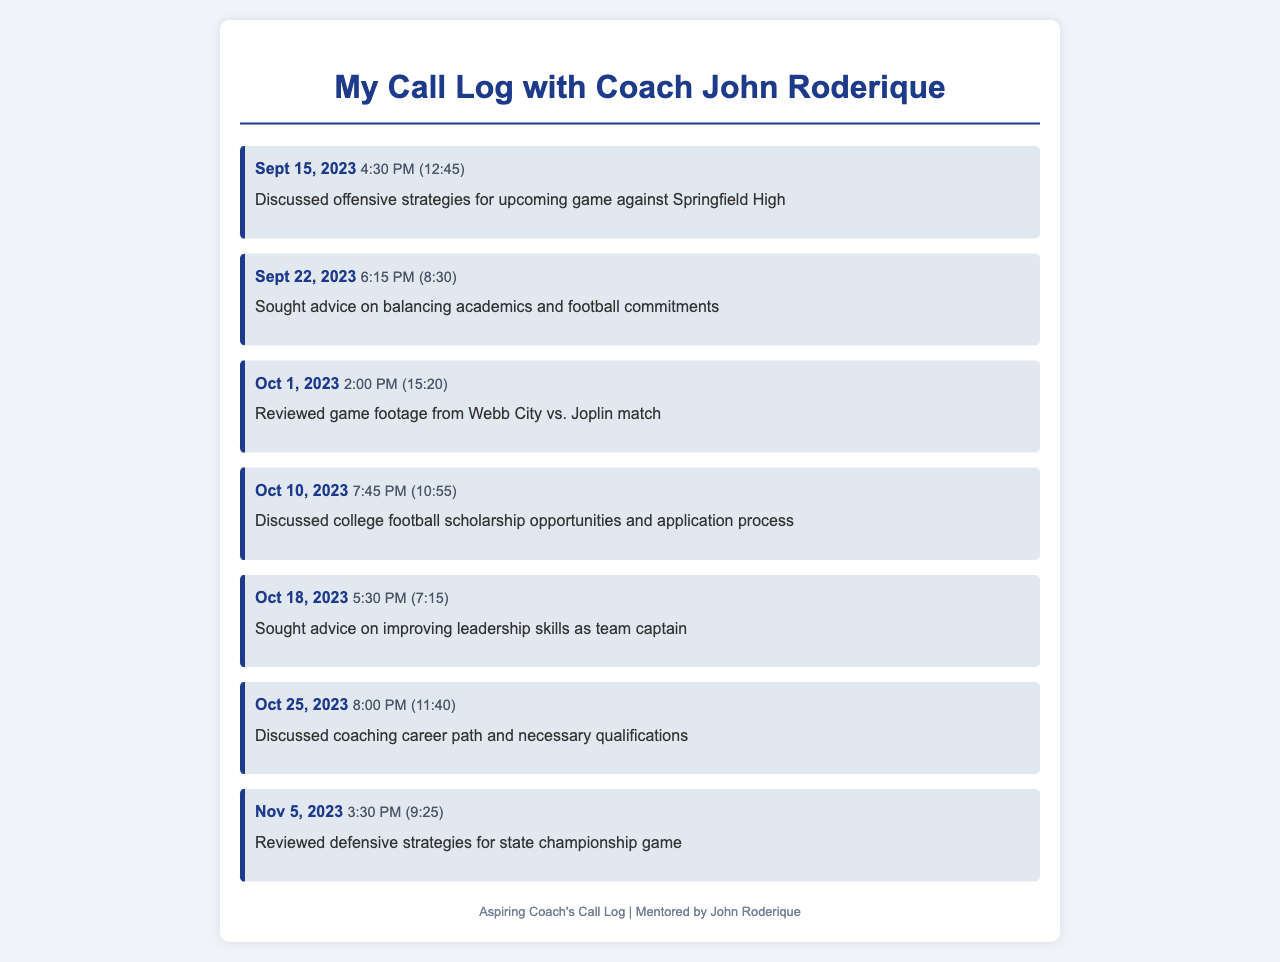what date was the call about offensive strategies? The call regarding offensive strategies took place on September 15, 2023.
Answer: September 15, 2023 how long was the call discussing leadership skills? The duration of the call discussing leadership skills was 7 minutes and 15 seconds.
Answer: 7:15 what was discussed on October 10, 2023? On October 10, 2023, the discussion focused on college football scholarship opportunities and the application process.
Answer: College football scholarship opportunities how many calls were made in October? There were three calls made in October 2023.
Answer: 3 which call had the longest duration? The call with the longest duration was on October 1, 2023, lasting 15 minutes and 20 seconds.
Answer: 15:20 what time was the call about improving leadership skills? The call about improving leadership skills took place at 5:30 PM.
Answer: 5:30 PM what was the main topic of the call on November 5, 2023? The main topic of the call on November 5, 2023, was reviewing defensive strategies for the state championship game.
Answer: Defensive strategies for state championship game how many calls discussed future career options? There were two calls discussing future career options.
Answer: 2 